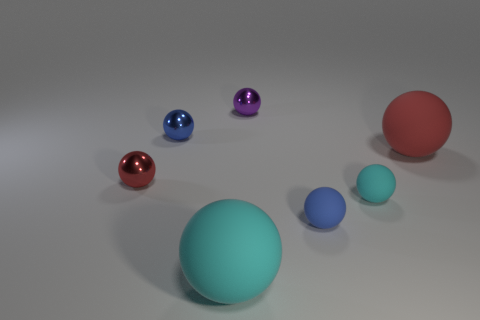Are there any large gray balls?
Your answer should be compact. No. Do the blue rubber thing and the red thing in front of the red rubber sphere have the same shape?
Your answer should be compact. Yes. What material is the blue ball right of the blue object behind the large red rubber thing?
Give a very brief answer. Rubber. There is a large matte thing that is left of the purple shiny thing; is it the same color as the tiny metal object to the right of the big cyan object?
Your response must be concise. No. There is a blue matte object that is the same shape as the small purple thing; what size is it?
Offer a terse response. Small. How many objects are small blue matte spheres in front of the small red sphere or tiny balls?
Offer a terse response. 5. The small thing that is the same material as the tiny cyan ball is what color?
Offer a terse response. Blue. Are there any cyan things that have the same size as the purple metal sphere?
Provide a short and direct response. Yes. How many things are either large matte things in front of the small cyan rubber sphere or shiny objects left of the blue metallic object?
Your response must be concise. 2. What shape is the blue shiny thing that is the same size as the red metallic sphere?
Your answer should be compact. Sphere. 